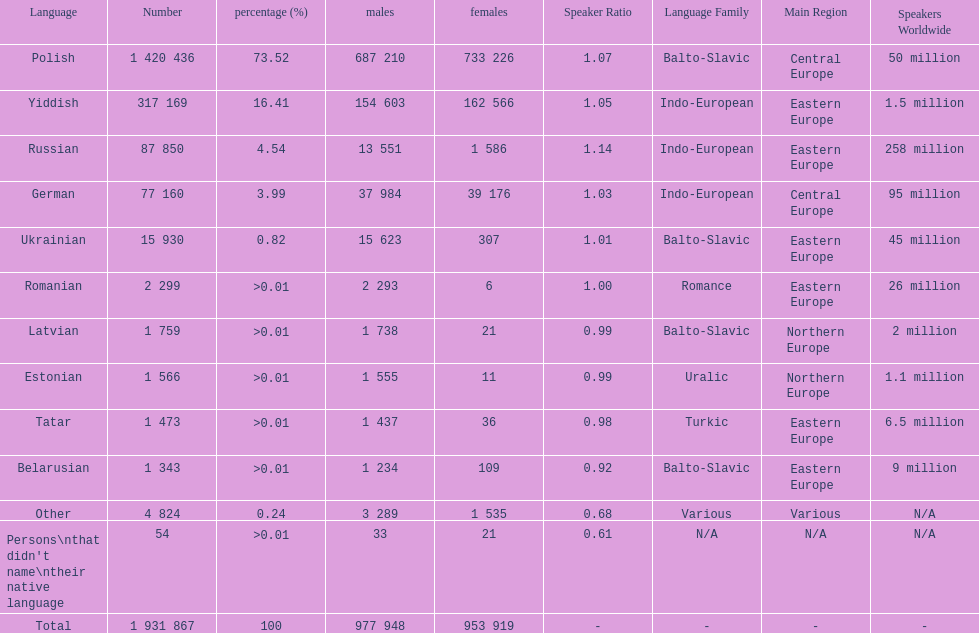Which language had the least number of females speaking it? Romanian. 